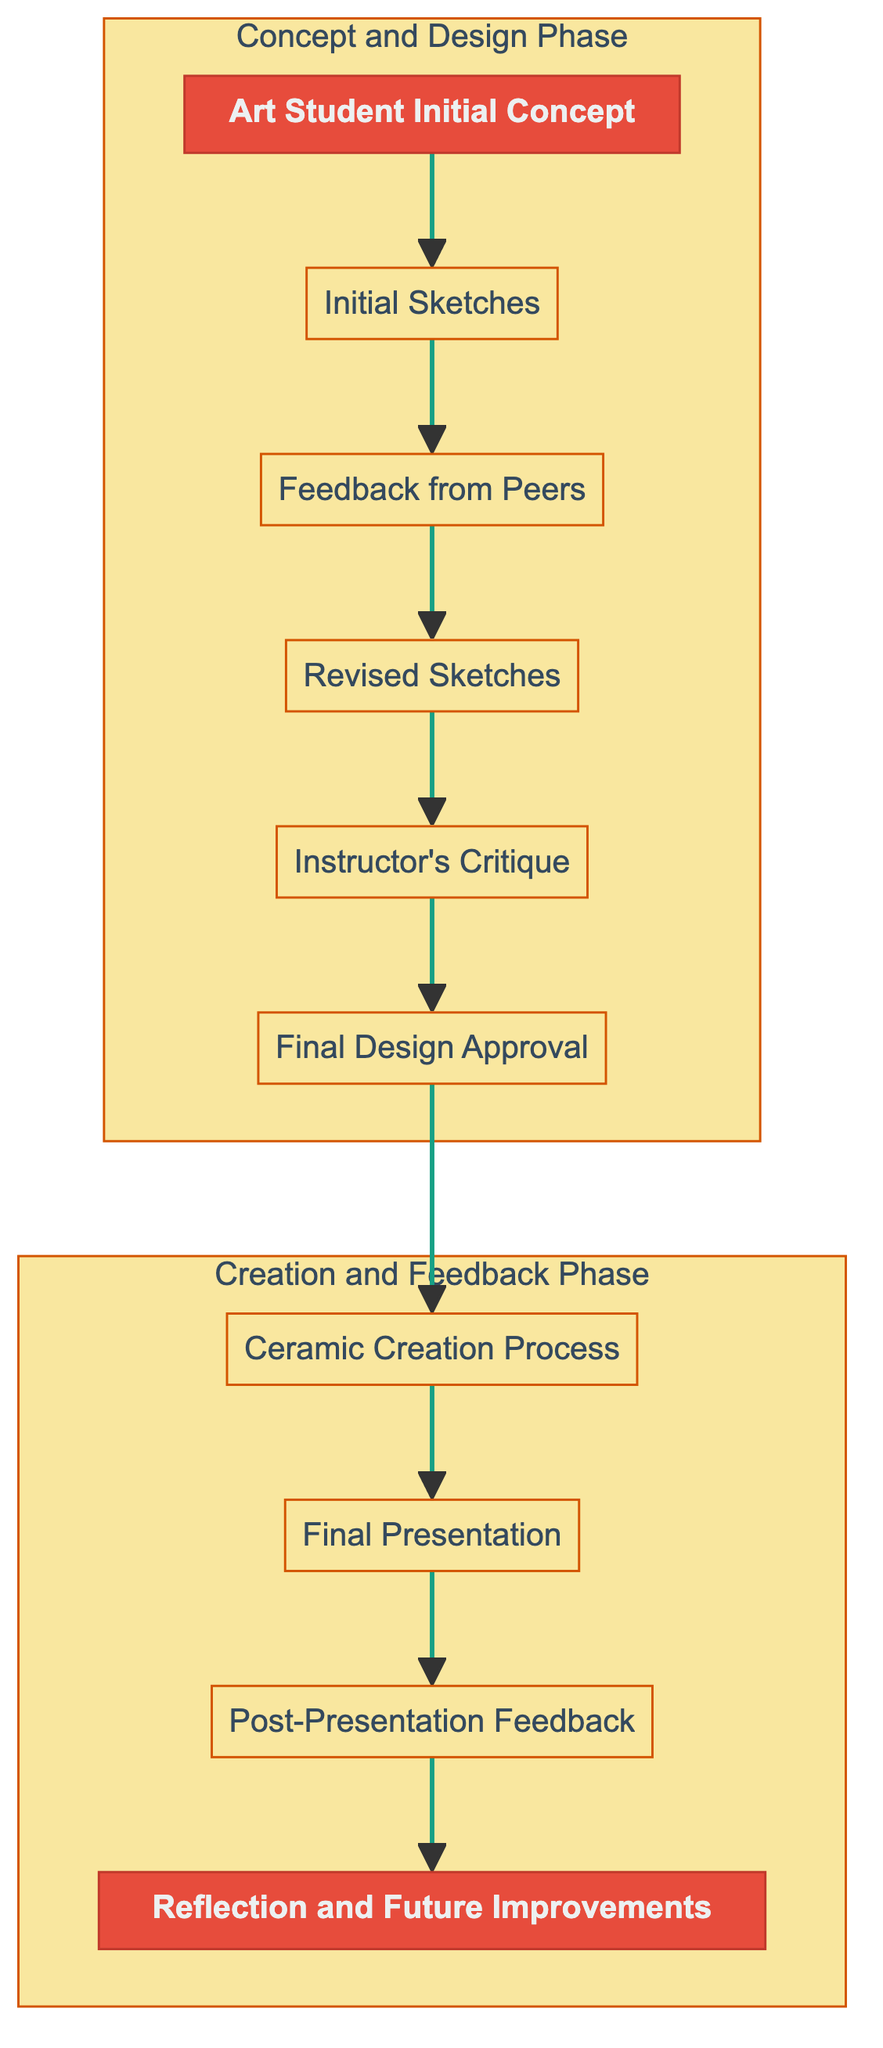What is the starting point of the flow chart? The first node labeled "Art Student Initial Concept" represents the beginning of the flow chart, indicating the student's original idea or inspiration.
Answer: Art Student Initial Concept How many nodes are there in the diagram? By counting the elements listed, we determine that there are ten distinct nodes, each representing a step in the flow of feedback and revisions.
Answer: 10 What node comes immediately after "Initial Sketches"? The flow indicates that after "Initial Sketches," the next step is receiving "Feedback from Peers," forming a direct connection in the process.
Answer: Feedback from Peers Which phase includes the "Ceramic Creation Process"? The node "Ceramic Creation Process" is part of the "Creation and Feedback Phase," indicating that it occurs after the design has been finalized and just before the final presentations.
Answer: Creation and Feedback Phase What is the final step after "Post-Presentation Feedback"? The diagram shows that the last step after "Post-Presentation Feedback" is "Reflection and Future Improvements," representing the concluding thoughts of the student on the project.
Answer: Reflection and Future Improvements Which node relies on feedback from both peers and the instructor? The node "Final Design Approval" relies on prior feedback received both from peers ("Feedback from Peers") and from the instructor's critique to finalize the design before the creation process.
Answer: Final Design Approval What are the two main phases defined in the diagram? The two distinct phases represented in the diagram are labeled as "Concept and Design Phase" and "Creation and Feedback Phase," encapsulating the entire process from conception to completion.
Answer: Concept and Design Phase, Creation and Feedback Phase How does the feedback loop affect the design process? The diagram shows that feedback from peers and the instructor leads to revisions, indicating a cyclical improvement process that enhances the quality of the design before final approval.
Answer: It enhances design quality What is the purpose of the "Final Presentation"? "Final Presentation" serves as a platform for the student to showcase the completed ceramic work and gather additional feedback from peers and instructors, contributing to overall improvement.
Answer: Gathering additional feedback 